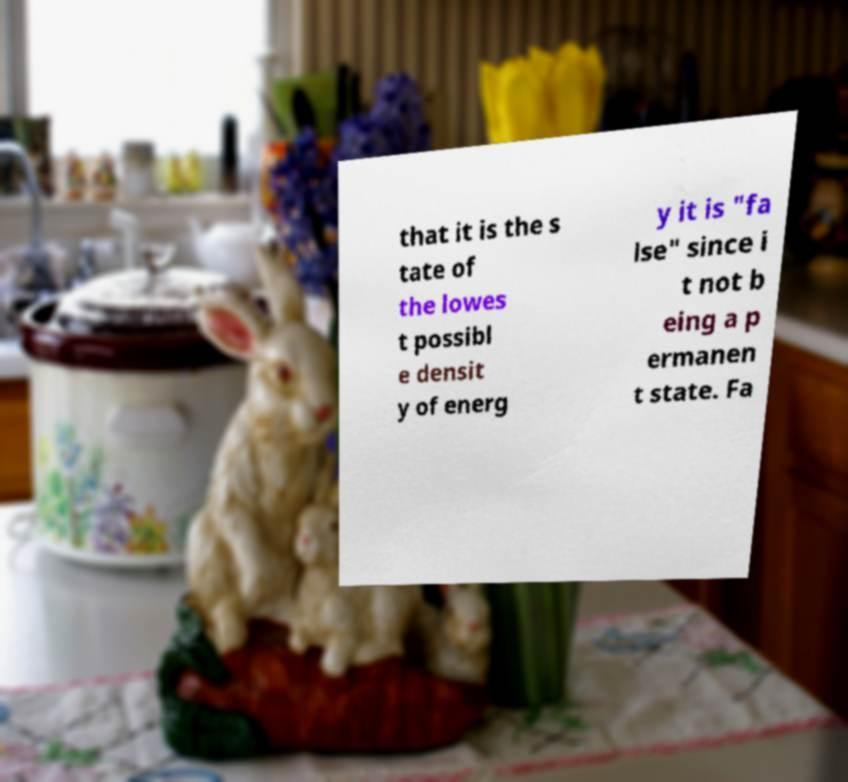What messages or text are displayed in this image? I need them in a readable, typed format. that it is the s tate of the lowes t possibl e densit y of energ y it is "fa lse" since i t not b eing a p ermanen t state. Fa 